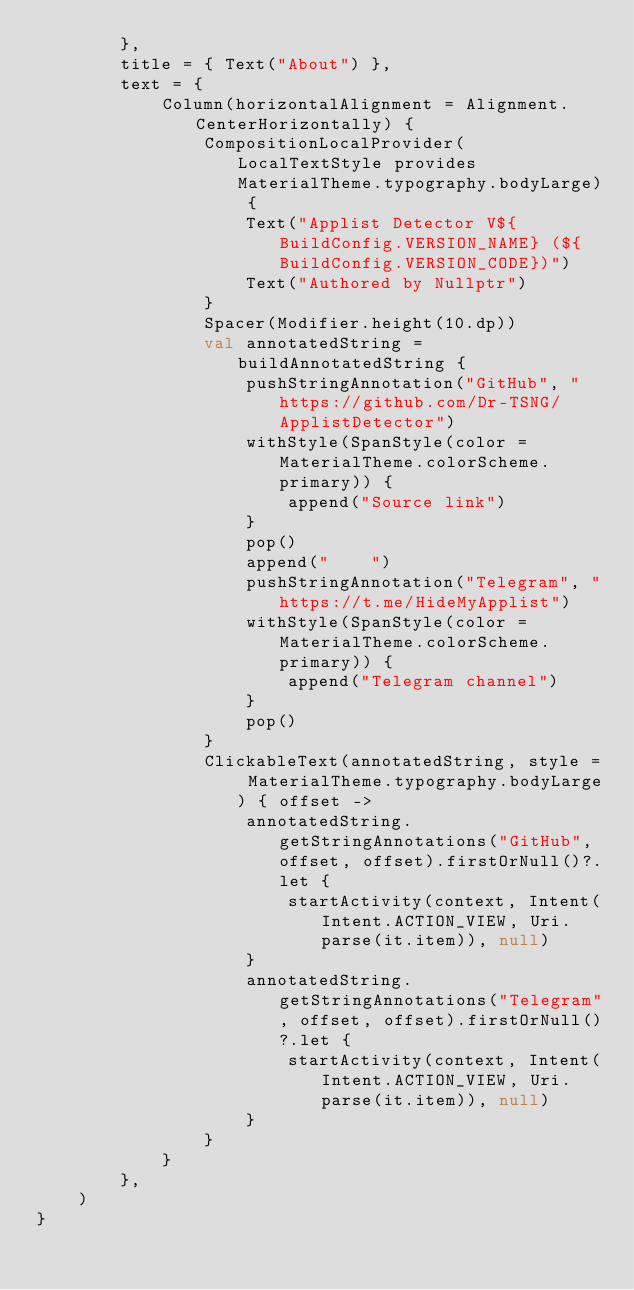<code> <loc_0><loc_0><loc_500><loc_500><_Kotlin_>        },
        title = { Text("About") },
        text = {
            Column(horizontalAlignment = Alignment.CenterHorizontally) {
                CompositionLocalProvider(LocalTextStyle provides MaterialTheme.typography.bodyLarge) {
                    Text("Applist Detector V${BuildConfig.VERSION_NAME} (${BuildConfig.VERSION_CODE})")
                    Text("Authored by Nullptr")
                }
                Spacer(Modifier.height(10.dp))
                val annotatedString = buildAnnotatedString {
                    pushStringAnnotation("GitHub", "https://github.com/Dr-TSNG/ApplistDetector")
                    withStyle(SpanStyle(color = MaterialTheme.colorScheme.primary)) {
                        append("Source link")
                    }
                    pop()
                    append("    ")
                    pushStringAnnotation("Telegram", "https://t.me/HideMyApplist")
                    withStyle(SpanStyle(color = MaterialTheme.colorScheme.primary)) {
                        append("Telegram channel")
                    }
                    pop()
                }
                ClickableText(annotatedString, style = MaterialTheme.typography.bodyLarge) { offset ->
                    annotatedString.getStringAnnotations("GitHub", offset, offset).firstOrNull()?.let {
                        startActivity(context, Intent(Intent.ACTION_VIEW, Uri.parse(it.item)), null)
                    }
                    annotatedString.getStringAnnotations("Telegram", offset, offset).firstOrNull()?.let {
                        startActivity(context, Intent(Intent.ACTION_VIEW, Uri.parse(it.item)), null)
                    }
                }
            }
        },
    )
}
</code> 